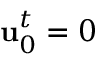<formula> <loc_0><loc_0><loc_500><loc_500>u _ { 0 } ^ { t } = 0</formula> 